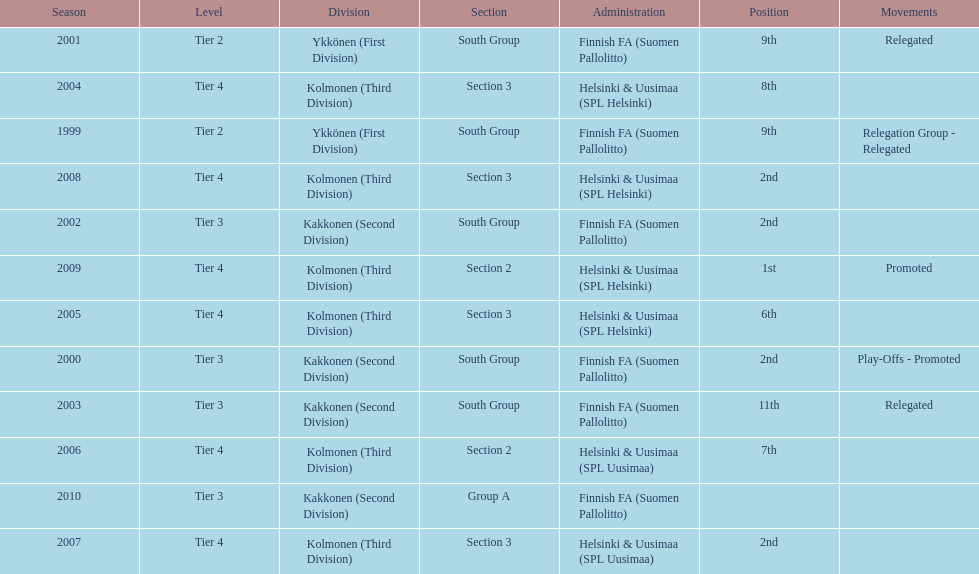How many times has this team been relegated? 3. 